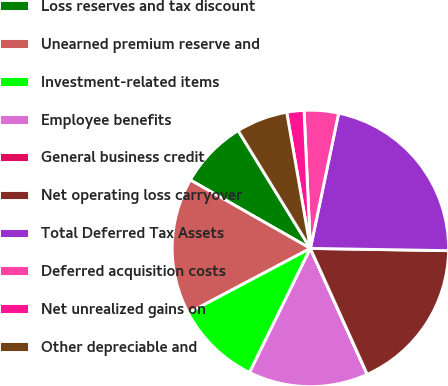Convert chart. <chart><loc_0><loc_0><loc_500><loc_500><pie_chart><fcel>Loss reserves and tax discount<fcel>Unearned premium reserve and<fcel>Investment-related items<fcel>Employee benefits<fcel>General business credit<fcel>Net operating loss carryover<fcel>Total Deferred Tax Assets<fcel>Deferred acquisition costs<fcel>Net unrealized gains on<fcel>Other depreciable and<nl><fcel>8.0%<fcel>15.99%<fcel>10.0%<fcel>13.99%<fcel>0.01%<fcel>17.99%<fcel>21.98%<fcel>4.01%<fcel>2.01%<fcel>6.01%<nl></chart> 